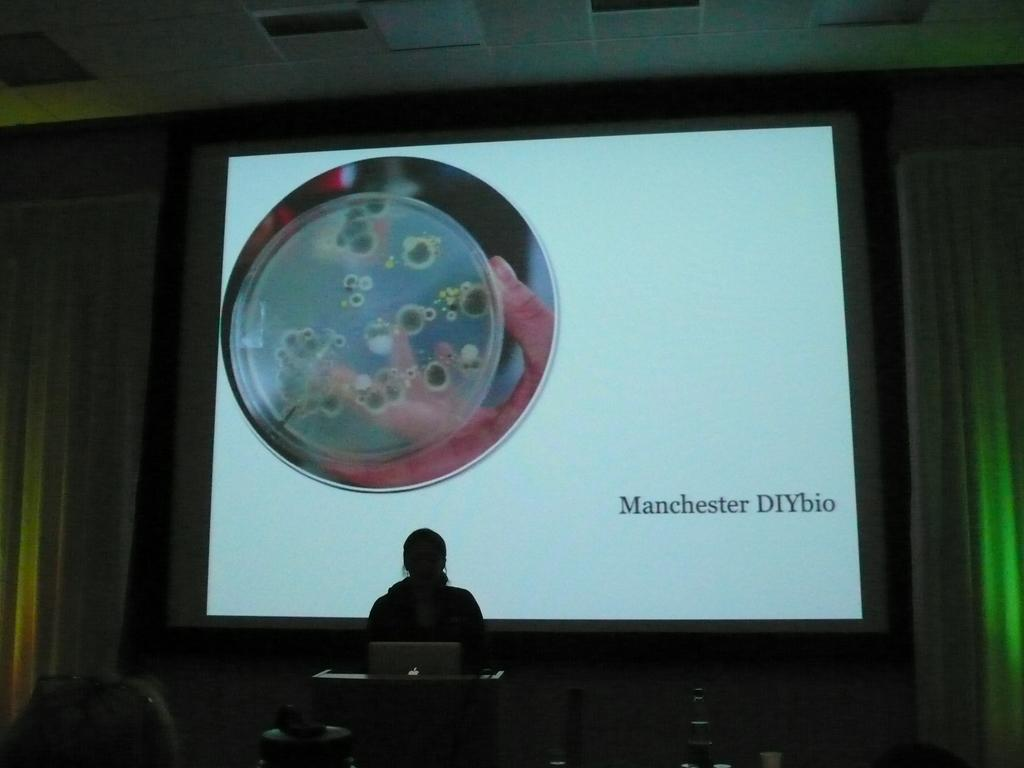<image>
Render a clear and concise summary of the photo. A person at a podium in front of a screen that says Manchester DIYbio. 